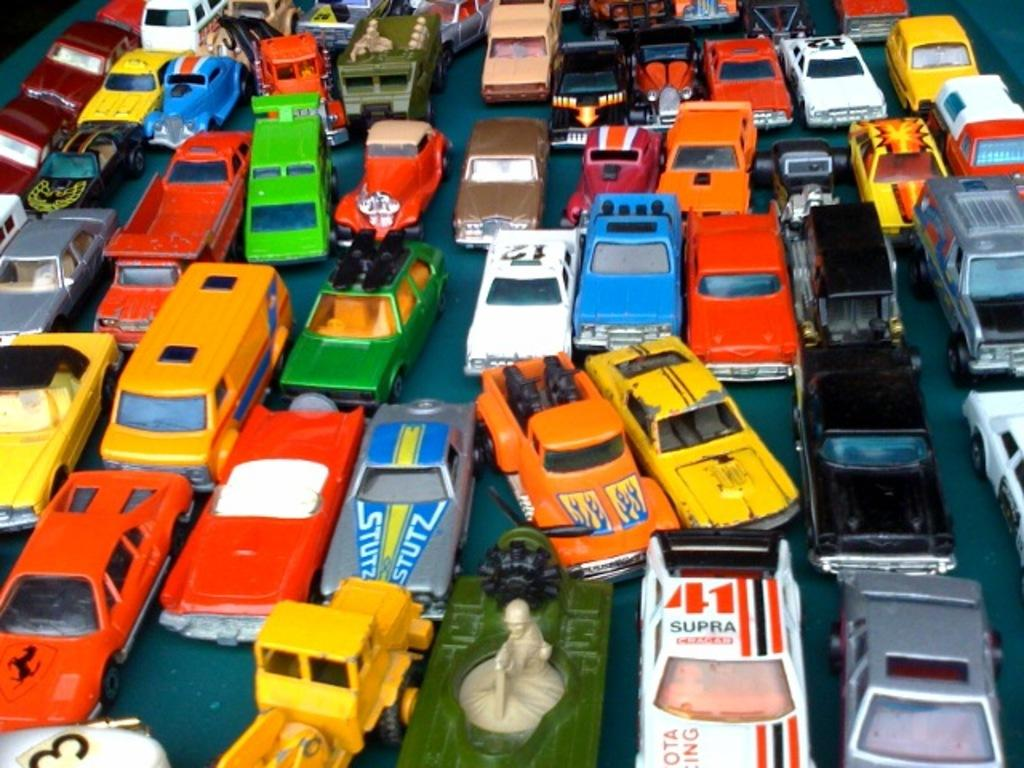<image>
Describe the image concisely. A traffic jam of toy cars including one that says 41 Supra on top. 